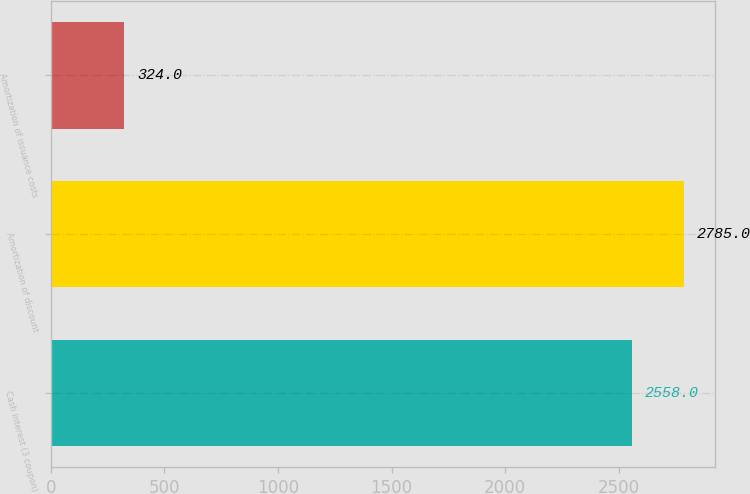Convert chart to OTSL. <chart><loc_0><loc_0><loc_500><loc_500><bar_chart><fcel>Cash interest (3 coupon)<fcel>Amortization of discount<fcel>Amortization of issuance costs<nl><fcel>2558<fcel>2785<fcel>324<nl></chart> 